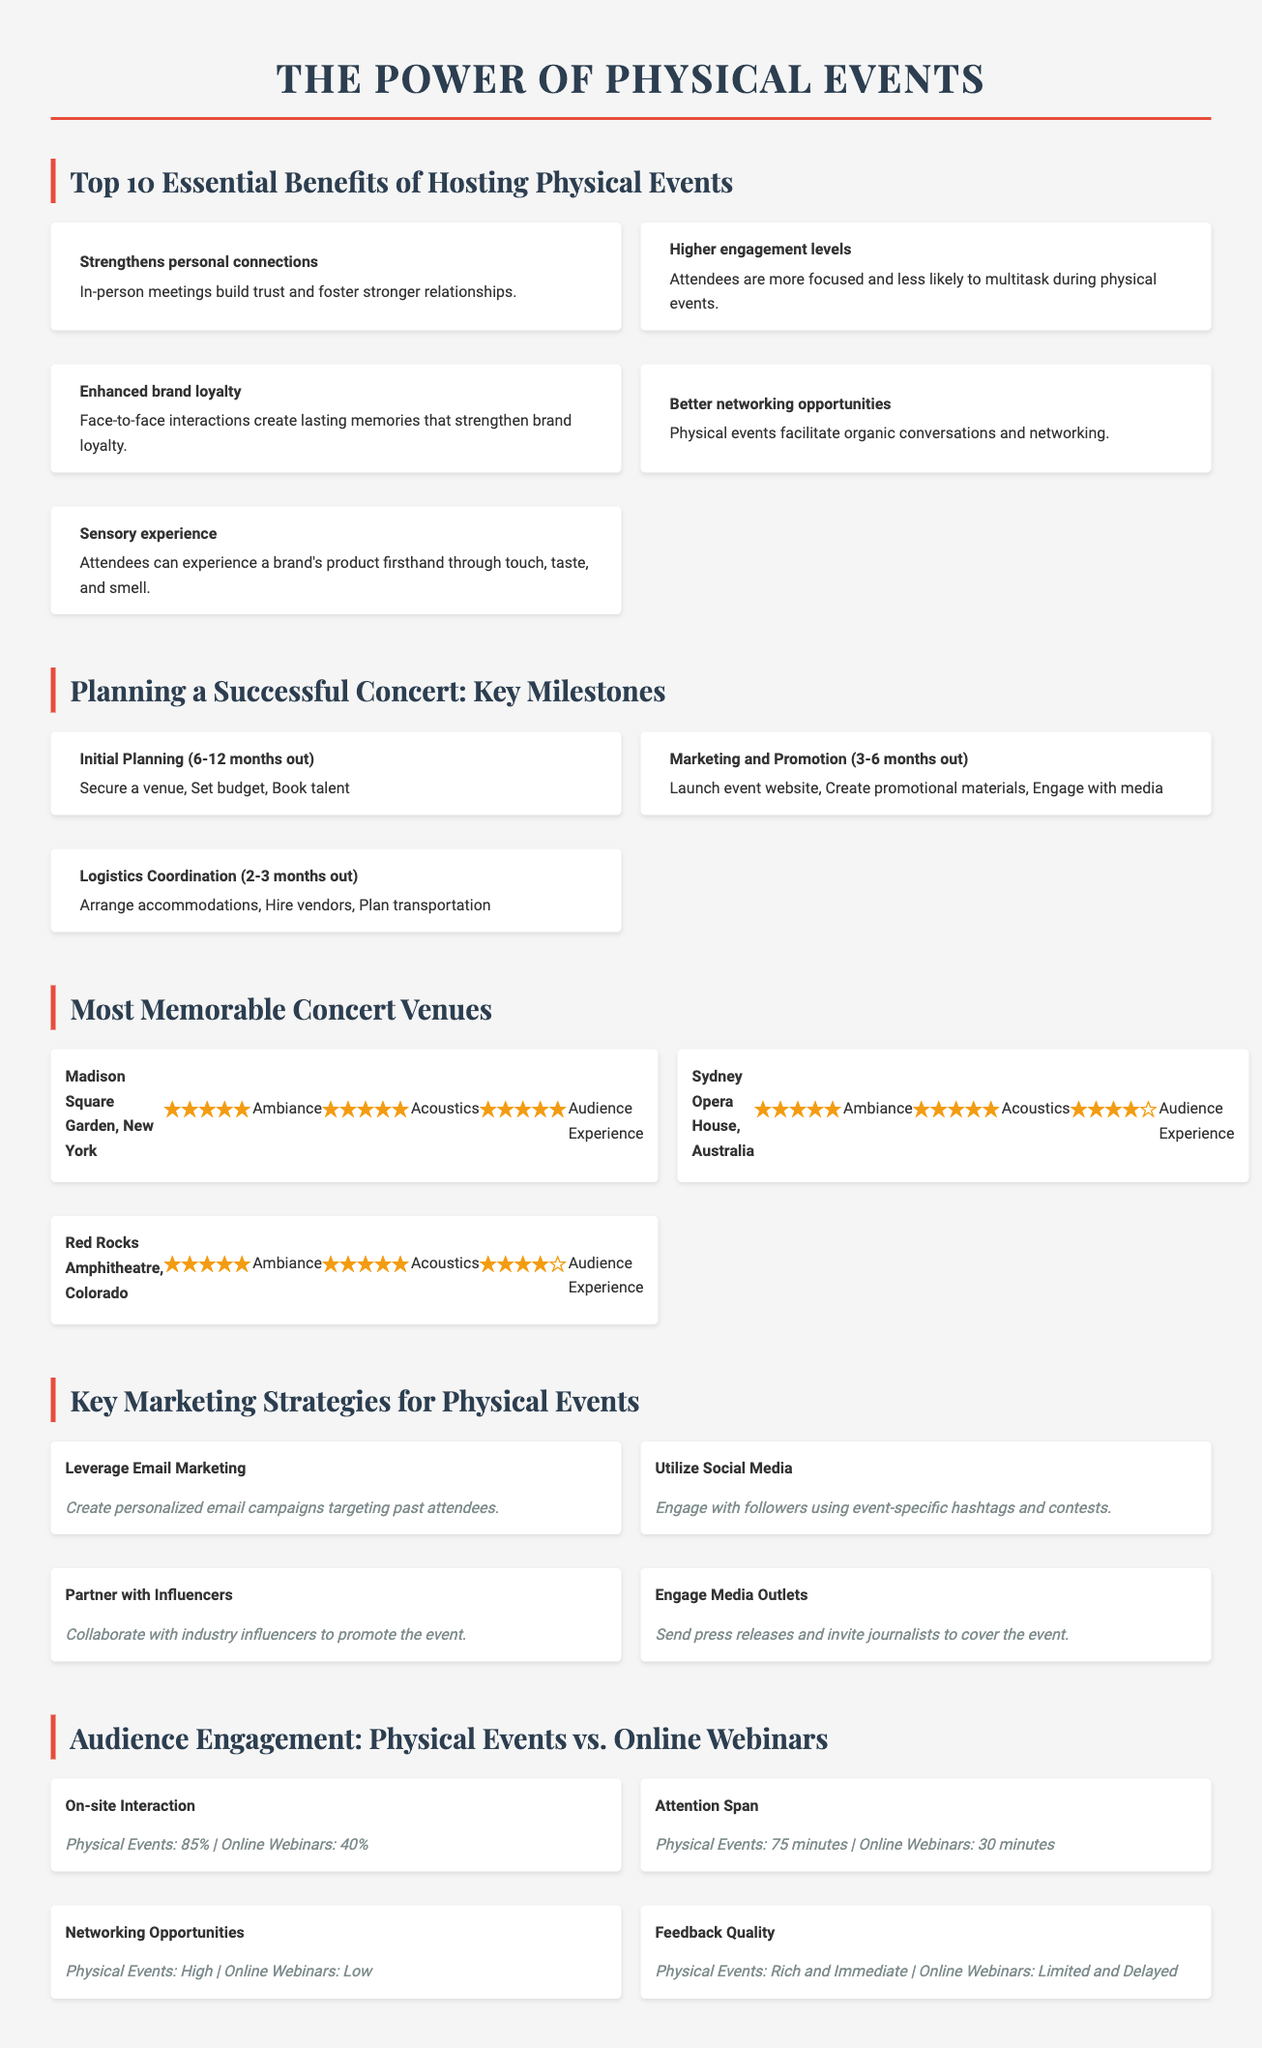What is the main title of the document? The main title is introduced at the beginning of the document, stating the focus on physical events.
Answer: The Power of Physical Events How many essential benefits of hosting physical events are listed? The number of benefits is explicitly mentioned in the heading of that section.
Answer: 10 What rating does Madison Square Garden receive for ambiance? The rating is provided alongside the venue's name in the venues section.
Answer: ★★★★★ What milestone comes first in planning a successful concert? This information is found in the checklist under the initial planning section.
Answer: Initial Planning (6-12 months out) What is the on-site interaction percentage for physical events? The percentage is provided in the comparison list under the on-site interaction category.
Answer: 85% Which marketing strategy involves creating personalized email campaigns? This strategy is reflected in the list under the key marketing strategies section.
Answer: Leverage Email Marketing What type of experiences do physical events provide that virtual events lack? The document discusses sensory experiences unique to physical events.
Answer: Sensory experience What is the attention span duration for online webinars? The document lists this detail within the comparison of engagement metrics.
Answer: 30 minutes How many concert venues are featured in the document? The number of venues is indicated in the section title.
Answer: 3 